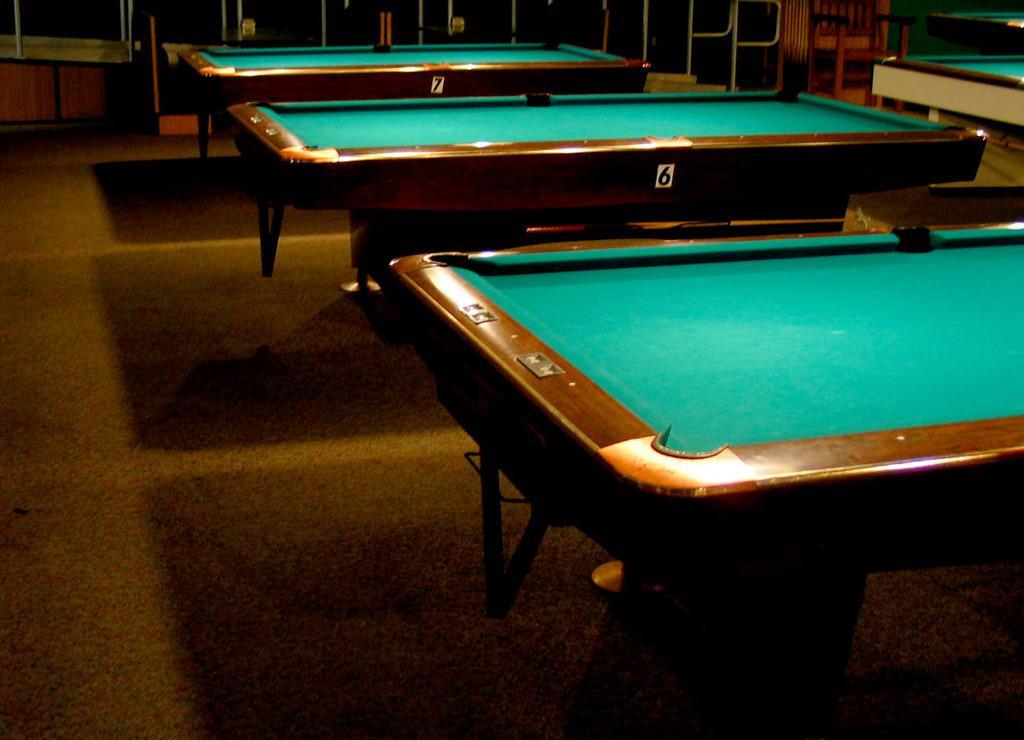How would you summarize this image in a sentence or two? there are 3 pool tables in this image. the tables are named as 6 and 7. 